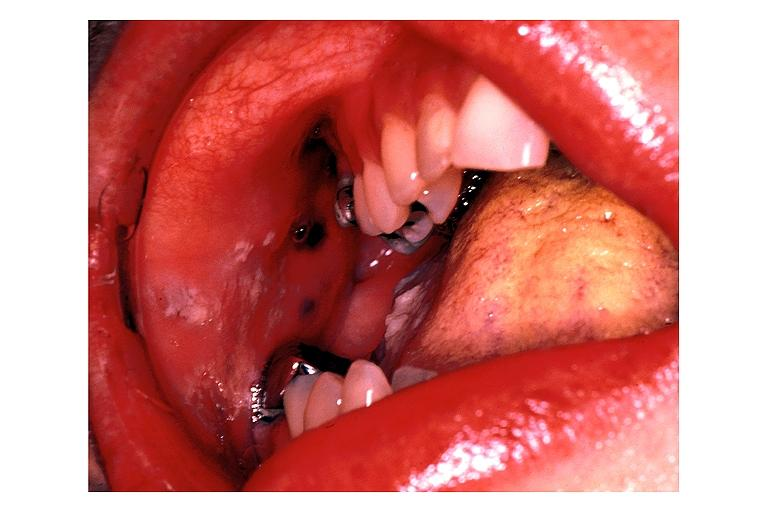s opened uterus and cervix with large cervical myoma protruding into vagina slide present?
Answer the question using a single word or phrase. No 